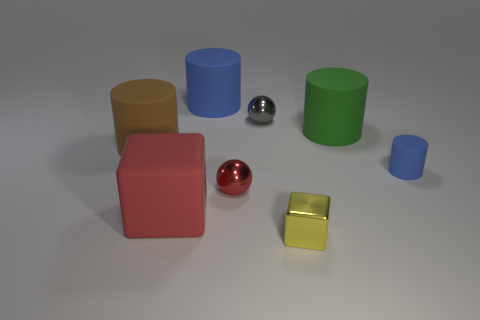Subtract all large cylinders. How many cylinders are left? 1 Subtract all brown cylinders. How many cylinders are left? 3 Add 1 large red cubes. How many objects exist? 9 Subtract all blocks. How many objects are left? 6 Subtract 2 cylinders. How many cylinders are left? 2 Subtract 0 yellow spheres. How many objects are left? 8 Subtract all purple spheres. Subtract all cyan cylinders. How many spheres are left? 2 Subtract all purple cylinders. How many brown spheres are left? 0 Subtract all tiny gray metallic spheres. Subtract all big red rubber cubes. How many objects are left? 6 Add 6 gray metal spheres. How many gray metal spheres are left? 7 